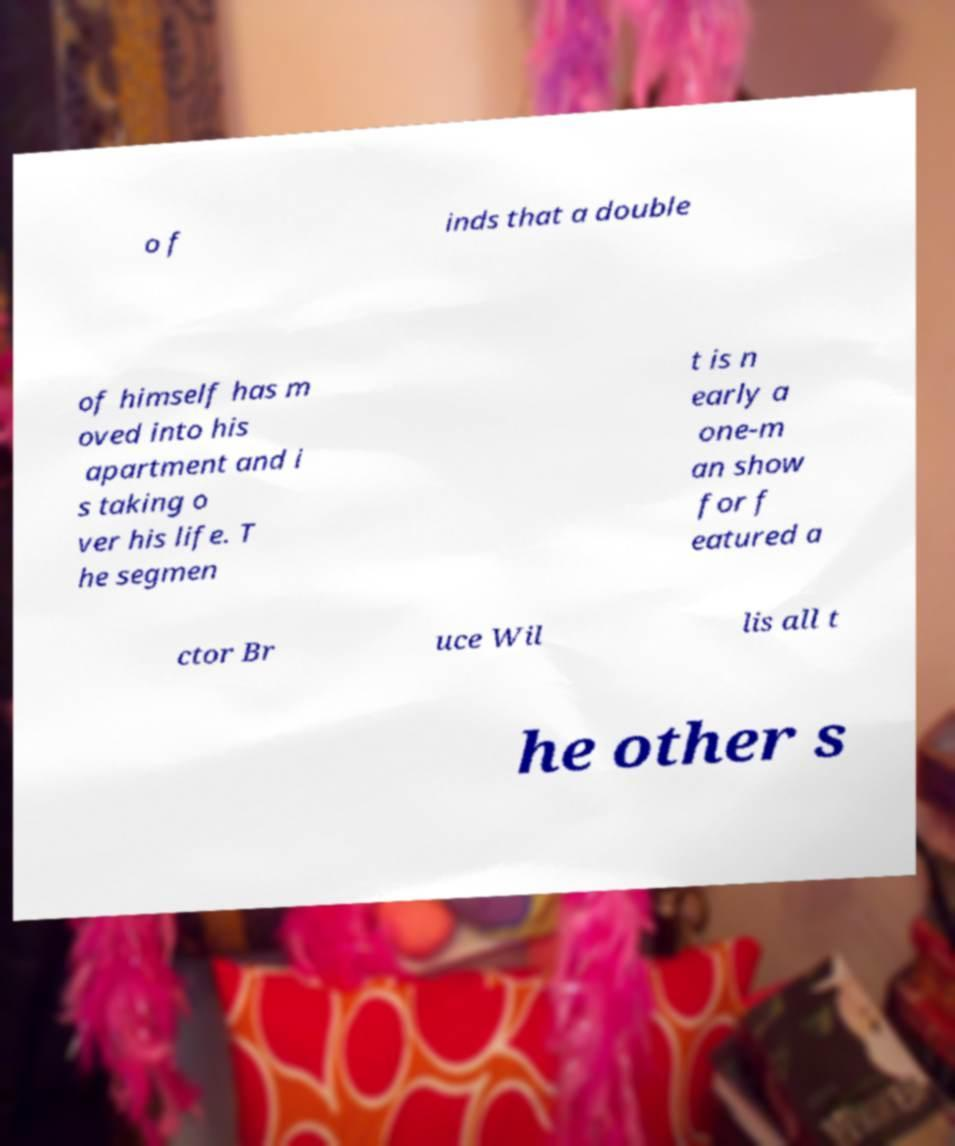Please identify and transcribe the text found in this image. o f inds that a double of himself has m oved into his apartment and i s taking o ver his life. T he segmen t is n early a one-m an show for f eatured a ctor Br uce Wil lis all t he other s 